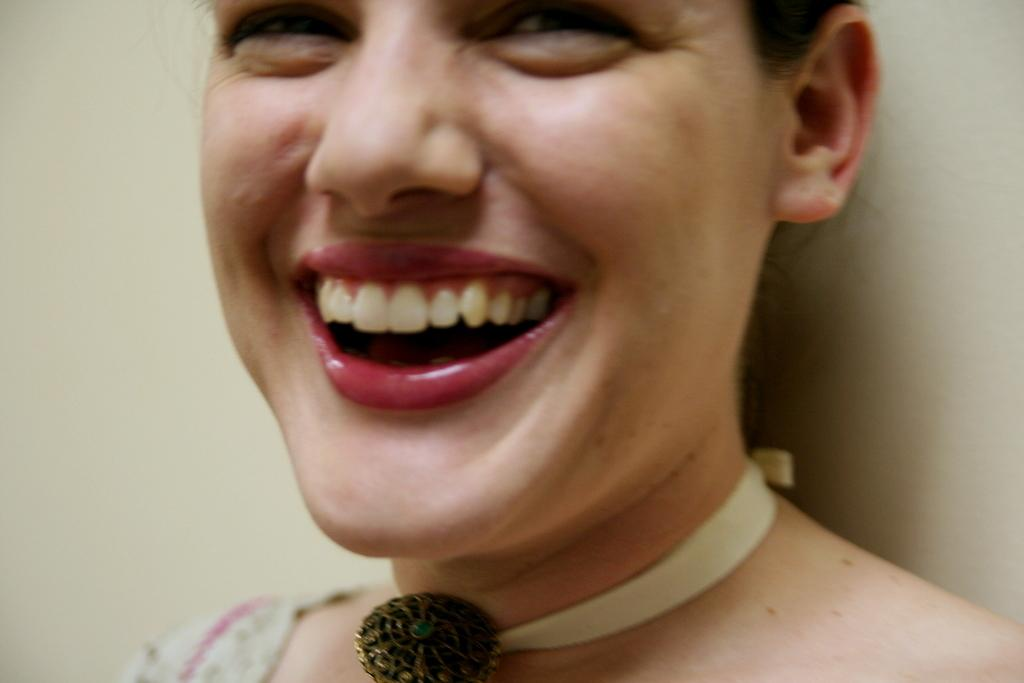Who is present in the image? There is a woman in the image. What is the woman doing in the image? The woman is smiling in the image. What can be seen behind the woman? There is a wall visible behind the woman. What type of juice is the woman holding in the image? There is no juice present in the image; the woman is not holding anything. 